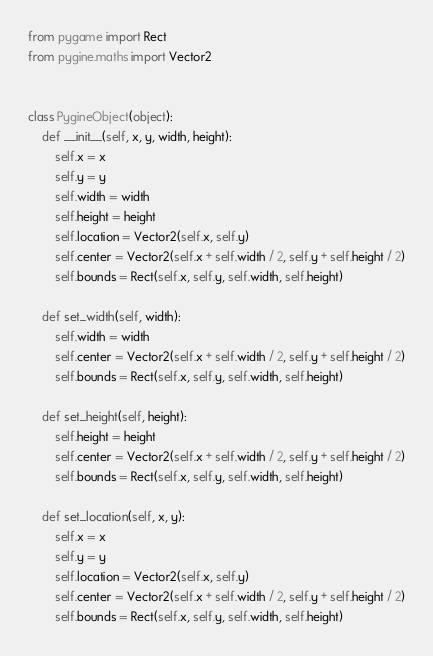<code> <loc_0><loc_0><loc_500><loc_500><_Python_>from pygame import Rect
from pygine.maths import Vector2


class PygineObject(object):
    def __init__(self, x, y, width, height):
        self.x = x
        self.y = y
        self.width = width
        self.height = height
        self.location = Vector2(self.x, self.y)
        self.center = Vector2(self.x + self.width / 2, self.y + self.height / 2)
        self.bounds = Rect(self.x, self.y, self.width, self.height)

    def set_width(self, width):
        self.width = width
        self.center = Vector2(self.x + self.width / 2, self.y + self.height / 2)
        self.bounds = Rect(self.x, self.y, self.width, self.height)

    def set_height(self, height):
        self.height = height
        self.center = Vector2(self.x + self.width / 2, self.y + self.height / 2)
        self.bounds = Rect(self.x, self.y, self.width, self.height)

    def set_location(self, x, y):
        self.x = x
        self.y = y
        self.location = Vector2(self.x, self.y)
        self.center = Vector2(self.x + self.width / 2, self.y + self.height / 2)
        self.bounds = Rect(self.x, self.y, self.width, self.height)
</code> 